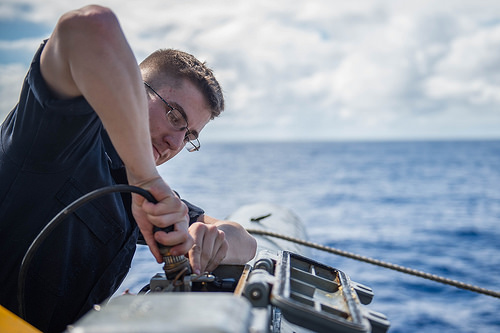<image>
Is there a man in front of the cloud? Yes. The man is positioned in front of the cloud, appearing closer to the camera viewpoint. 